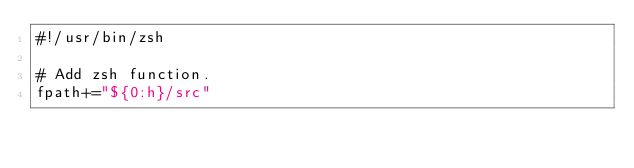<code> <loc_0><loc_0><loc_500><loc_500><_Bash_>#!/usr/bin/zsh

# Add zsh function.
fpath+="${0:h}/src"
</code> 